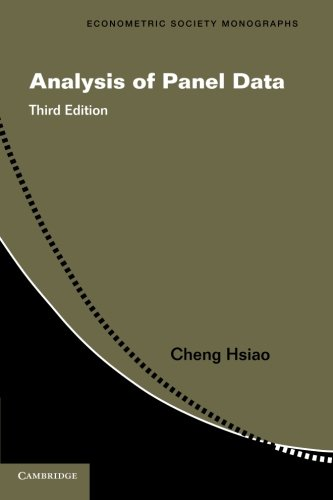Who is the author of this book? The author of this book, as shown on the cover, is Cheng Hsiao, a respected economist and professor known for his contributions to panel data analysis. 